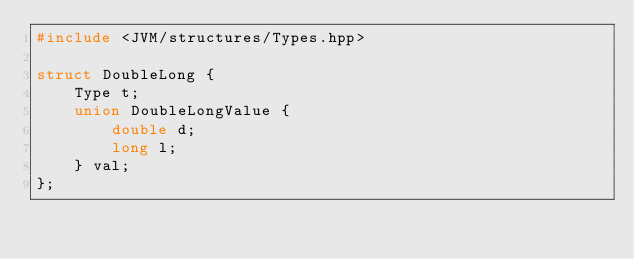<code> <loc_0><loc_0><loc_500><loc_500><_C++_>#include <JVM/structures/Types.hpp>

struct DoubleLong {
    Type t;
    union DoubleLongValue {
        double d;
        long l;
    } val;
};
</code> 